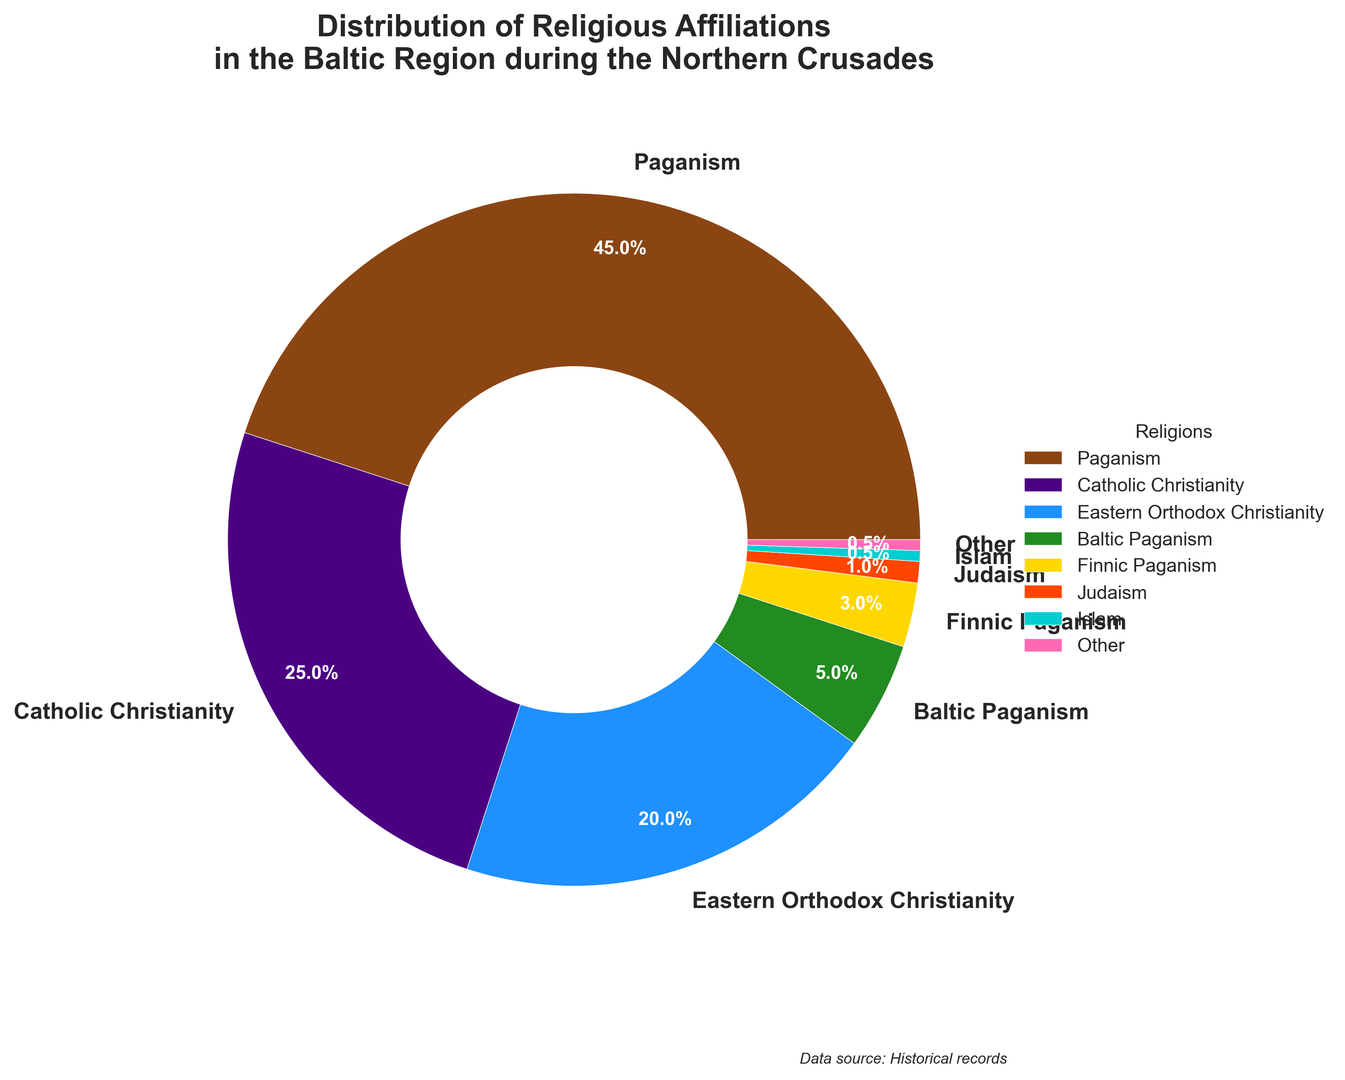What percentage of the population followed Paganism? The figure shows that Paganism takes up a large segment of the pie chart. By looking at the label for Paganism, we can see the percentage they represent.
Answer: 45% How does the percentage of Eastern Orthodox Christians compare to the percentage of Catholic Christians? The figure shows Eastern Orthodox Christianity is 20% and Catholic Christianity is 25%. Comparing the two, we find that Catholic Christianity is 5% higher than Eastern Orthodox Christianity.
Answer: Catholic Christianity is 5% higher What is the combined percentage of Baltic Paganism and Finnic Paganism? According to the chart, Baltic Paganism has 5% and Finnic Paganism has 3%. Adding these together, we get 5% + 3% = 8%.
Answer: 8% Which religion has the smallest representation and what percentage does it constitute? The pie chart shows that Judaism and Islam each have the smallest segments, but we need to look at the percentage label. Judaism has 1% and Islam has 0.5%, so Islam has the smallest representation.
Answer: Islam, 0.5% How much larger is the percentage of Paganism compared to the combined percentage of Judaism and Islam? Paganism is 45%. Judaism is 1% and Islam is 0.5%, so together they are 1% + 0.5% = 1.5%. Subtracting the combined percentage from Paganism, 45% - 1.5% = 43.5%.
Answer: 43.5% What color represents Eastern Orthodox Christianity? By looking at the pie chart, we can identify the color segment corresponding to Eastern Orthodox Christianity, which is labeled with its percentage.
Answer: Blue What are the three least represented religious affiliations and their combined percentage? Looking at the chart, the least represented religious affiliations are Judaism (1%), Islam (0.5%), and Other (0.5%). Adding these together, 1% + 0.5% + 0.5% = 2%.
Answer: Judaism, Islam, Other; 2% What percentage more popular is Catholic Christianity than Baltic Paganism? The chart shows Catholic Christianity is 25% and Baltic Paganism is 5%. Subtracting Baltic Paganism's percentage from Catholic Christianity's, 25% - 5% = 20%.
Answer: 20% What religion does the green-colored segment represent? By looking at the pie chart, we identify the green-colored segment and check its label and percentage to determine the religion it represents.
Answer: Baltic Paganism 